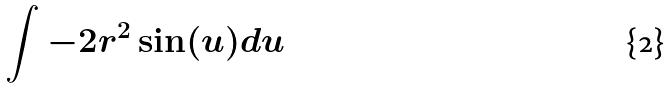Convert formula to latex. <formula><loc_0><loc_0><loc_500><loc_500>\int - 2 r ^ { 2 } \sin ( u ) d u</formula> 